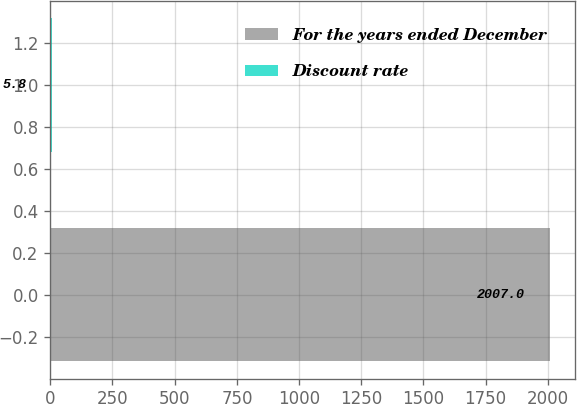<chart> <loc_0><loc_0><loc_500><loc_500><bar_chart><fcel>For the years ended December<fcel>Discount rate<nl><fcel>2007<fcel>5.8<nl></chart> 